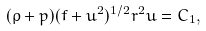Convert formula to latex. <formula><loc_0><loc_0><loc_500><loc_500>( \rho + p ) ( f + u ^ { 2 } ) ^ { 1 / 2 } r ^ { 2 } u = C _ { 1 } ,</formula> 